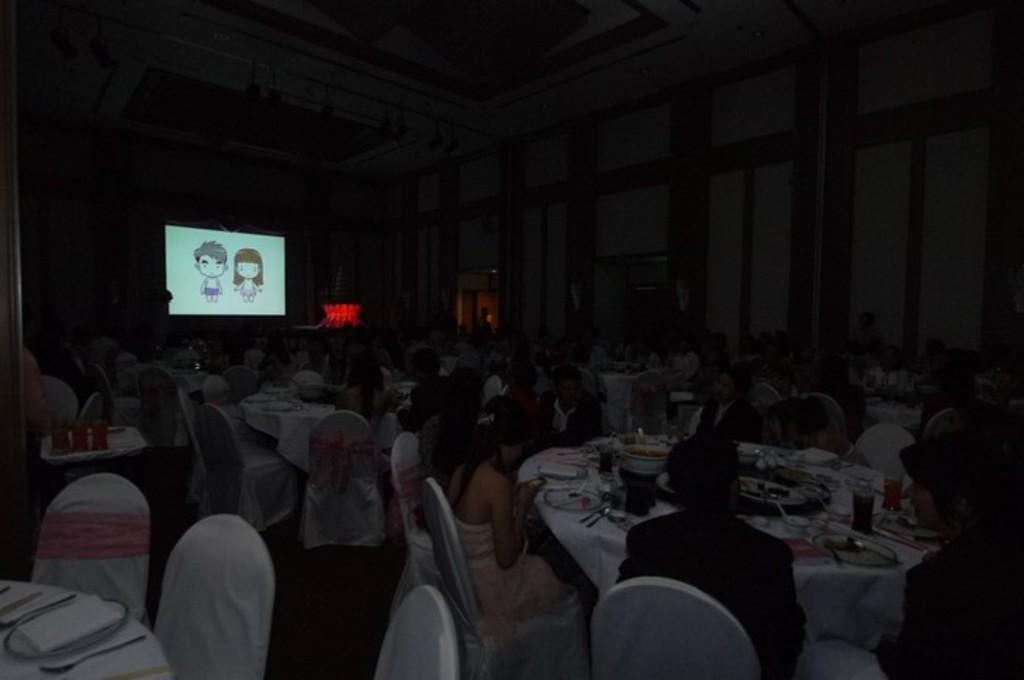How would you summarize this image in a sentence or two? In this picture there are some people sitting around the table on which some food items, glasses were placed. There is dark. In the background, there is a display here. We can observe a wall in the background. 